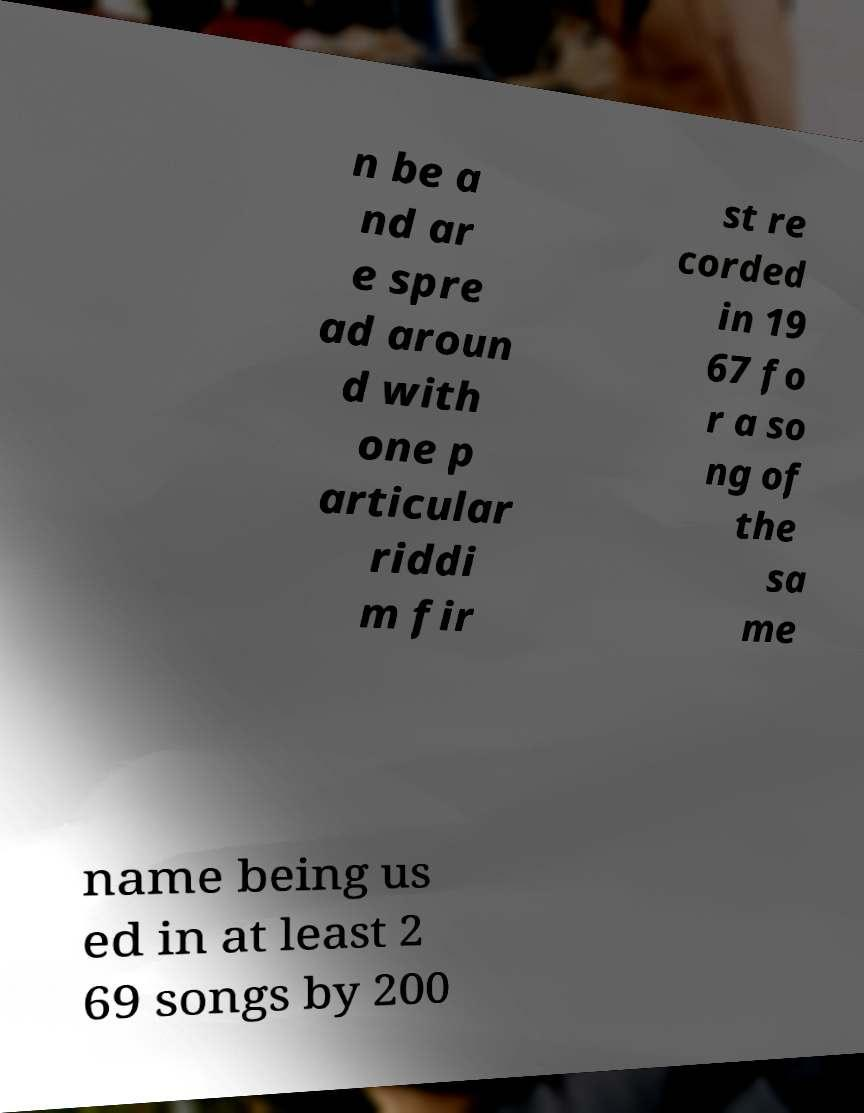For documentation purposes, I need the text within this image transcribed. Could you provide that? n be a nd ar e spre ad aroun d with one p articular riddi m fir st re corded in 19 67 fo r a so ng of the sa me name being us ed in at least 2 69 songs by 200 